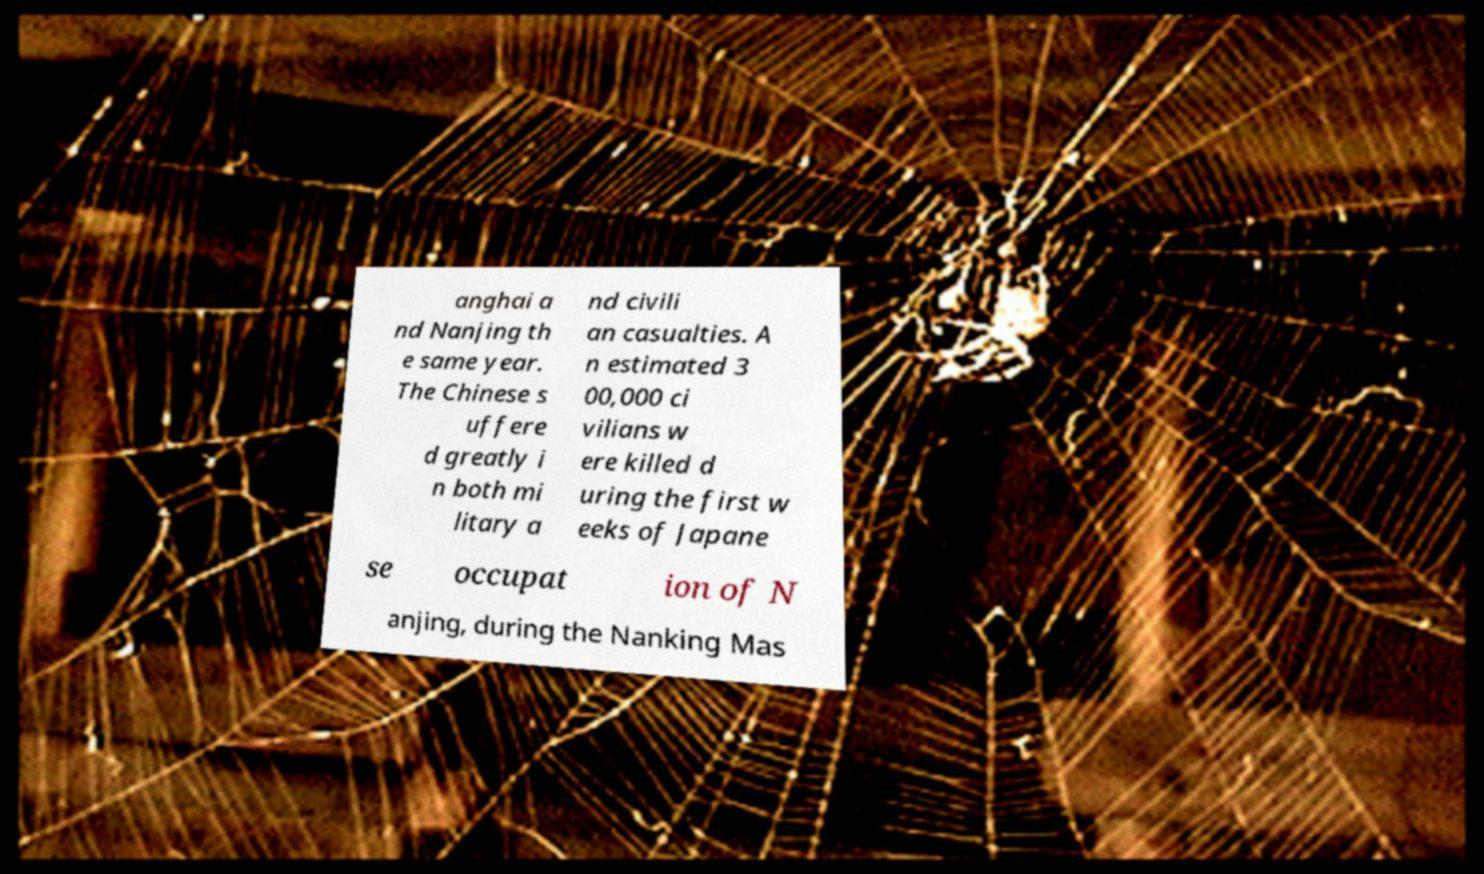Can you accurately transcribe the text from the provided image for me? anghai a nd Nanjing th e same year. The Chinese s uffere d greatly i n both mi litary a nd civili an casualties. A n estimated 3 00,000 ci vilians w ere killed d uring the first w eeks of Japane se occupat ion of N anjing, during the Nanking Mas 